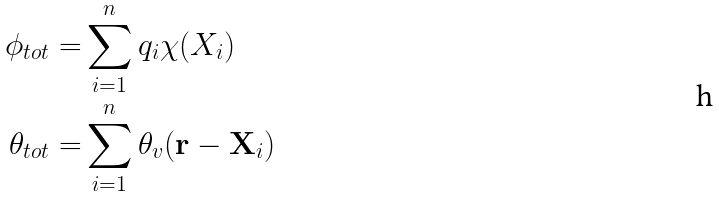Convert formula to latex. <formula><loc_0><loc_0><loc_500><loc_500>\phi _ { t o t } = & \sum _ { i = 1 } ^ { n } q _ { i } \chi ( X _ { i } ) \\ \theta _ { t o t } = & \sum _ { i = 1 } ^ { n } \theta _ { v } ( \mathbf r - \mathbf X _ { i } )</formula> 